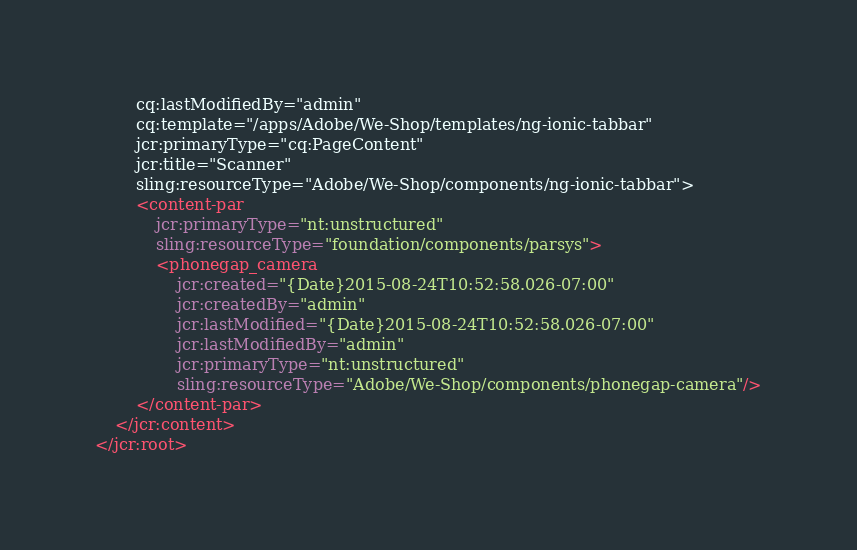<code> <loc_0><loc_0><loc_500><loc_500><_XML_>        cq:lastModifiedBy="admin"
        cq:template="/apps/Adobe/We-Shop/templates/ng-ionic-tabbar"
        jcr:primaryType="cq:PageContent"
        jcr:title="Scanner"
        sling:resourceType="Adobe/We-Shop/components/ng-ionic-tabbar">
        <content-par
            jcr:primaryType="nt:unstructured"
            sling:resourceType="foundation/components/parsys">
            <phonegap_camera
                jcr:created="{Date}2015-08-24T10:52:58.026-07:00"
                jcr:createdBy="admin"
                jcr:lastModified="{Date}2015-08-24T10:52:58.026-07:00"
                jcr:lastModifiedBy="admin"
                jcr:primaryType="nt:unstructured"
                sling:resourceType="Adobe/We-Shop/components/phonegap-camera"/>
        </content-par>
    </jcr:content>
</jcr:root>
</code> 